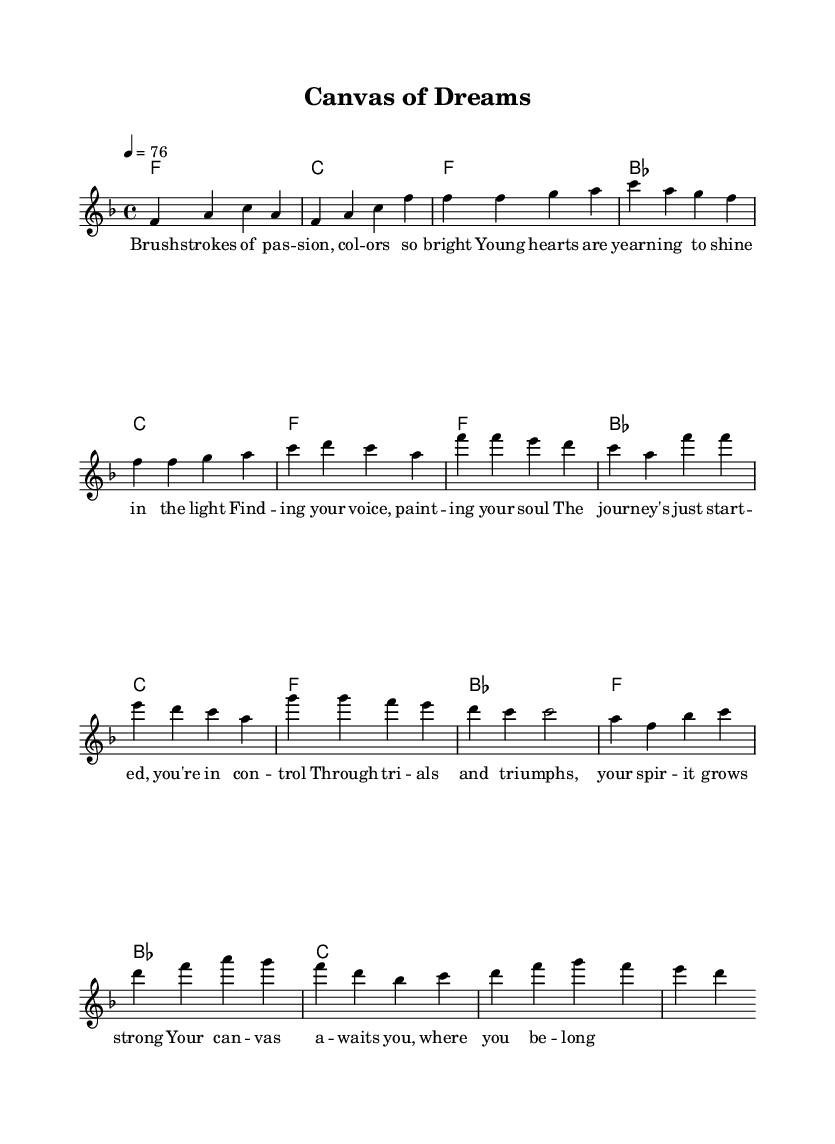What is the key signature of this music? The key signature is F major, which has one flat (B flat). This can be determined by looking at the key signature indicated near the beginning of the score.
Answer: F major What is the time signature of the piece? The time signature is 4/4, which is indicated at the beginning of the score. This means there are four beats in each measure.
Answer: 4/4 What is the tempo marking of the piece? The tempo marking indicates the piece should be played at a speed of 76 beats per minute, as shown at the beginning of the score.
Answer: 76 How many measures are there in the chorus? The chorus section consists of four measures, as inferred by counting from the start of the chorus until the end of that segment in the score.
Answer: 4 What is the first lyric line of the bridge? The first lyric line of the bridge is "Through trials and triumphs, your spirit grows strong." This can be found in the lyrics associated with the bridge section of the score.
Answer: Through trials and triumphs, your spirit grows strong What chord follows the introductory section? The chord that follows the intro is C. This is found in the harmonies section, where the chord progression after the intro indicates a shift.
Answer: C What element of Disco does this music highlight through its lyrics? The lyrics highlight the theme of self-discovery which is a common theme in Disco music, reflecting personal journeys and struggles through art and expression. This can be deduced from the content of the lyrics throughout the piece.
Answer: Self-discovery 